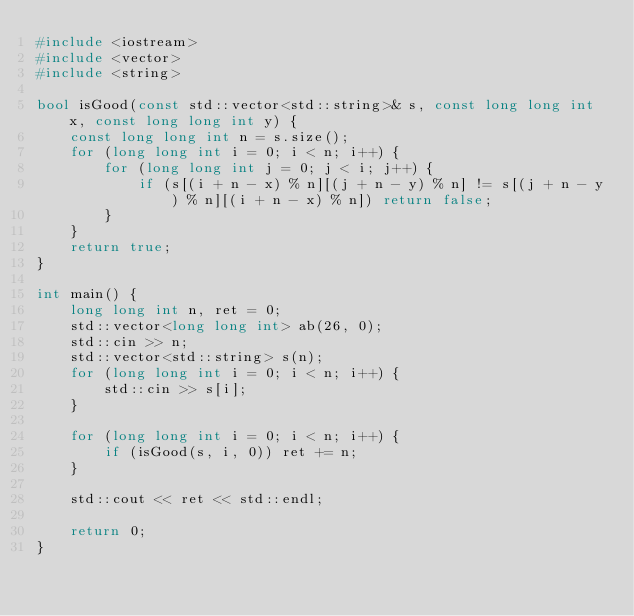<code> <loc_0><loc_0><loc_500><loc_500><_C++_>#include <iostream>
#include <vector>
#include <string>

bool isGood(const std::vector<std::string>& s, const long long int x, const long long int y) {
    const long long int n = s.size();
    for (long long int i = 0; i < n; i++) {
        for (long long int j = 0; j < i; j++) {
            if (s[(i + n - x) % n][(j + n - y) % n] != s[(j + n - y) % n][(i + n - x) % n]) return false;
        }
    }
    return true;
}

int main() {
    long long int n, ret = 0;
    std::vector<long long int> ab(26, 0);
    std::cin >> n;
    std::vector<std::string> s(n);
    for (long long int i = 0; i < n; i++) {
        std::cin >> s[i];
    }

    for (long long int i = 0; i < n; i++) {
        if (isGood(s, i, 0)) ret += n;
    }

    std::cout << ret << std::endl;

    return 0;
}</code> 